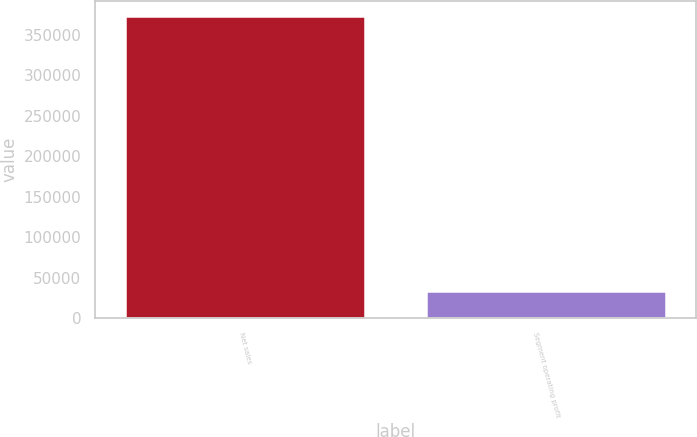Convert chart to OTSL. <chart><loc_0><loc_0><loc_500><loc_500><bar_chart><fcel>Net sales<fcel>Segment operating profit<nl><fcel>372359<fcel>34021<nl></chart> 